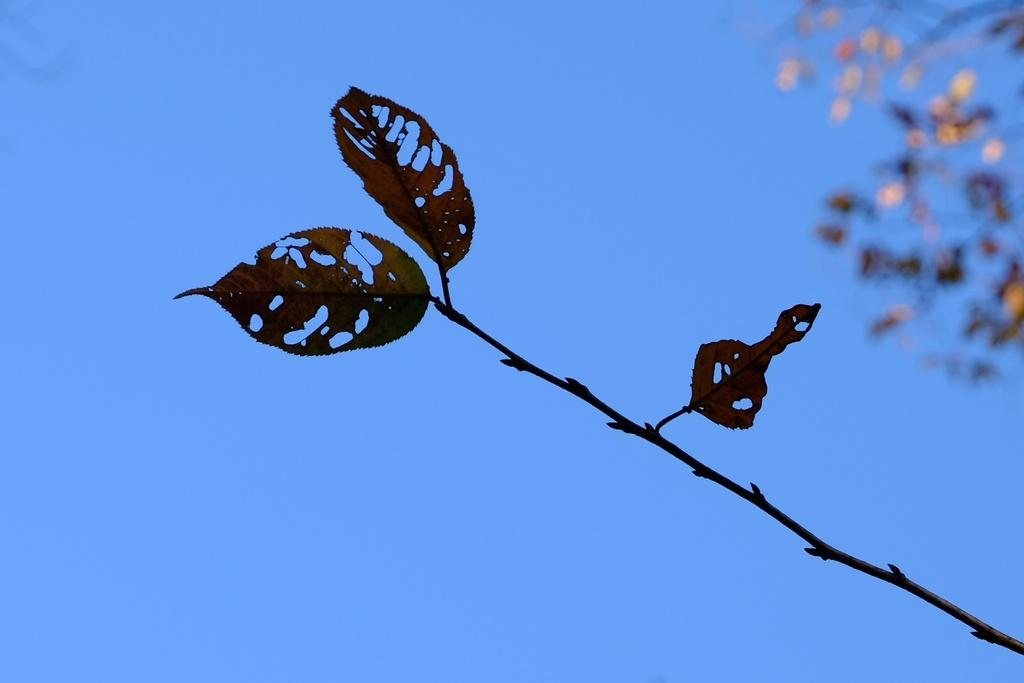What is the main subject of the image? The main subject of the image is a stem. What is attached to the stem? Leaves are attached to the stem. How would you describe the background of the image? The background of the image is blurred. What type of knife can be seen in the image? There is no knife present in the image; it features a stem and leaves. What kind of fuel is being used in the image? There is no fuel or any indication of fuel usage in the image. 